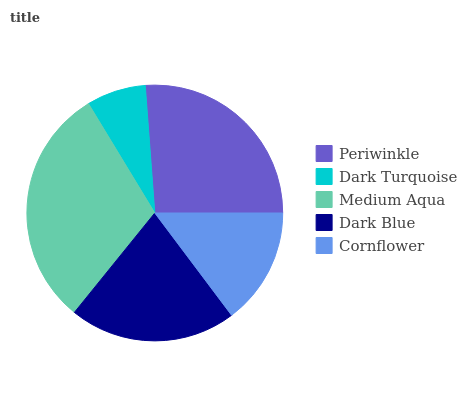Is Dark Turquoise the minimum?
Answer yes or no. Yes. Is Medium Aqua the maximum?
Answer yes or no. Yes. Is Medium Aqua the minimum?
Answer yes or no. No. Is Dark Turquoise the maximum?
Answer yes or no. No. Is Medium Aqua greater than Dark Turquoise?
Answer yes or no. Yes. Is Dark Turquoise less than Medium Aqua?
Answer yes or no. Yes. Is Dark Turquoise greater than Medium Aqua?
Answer yes or no. No. Is Medium Aqua less than Dark Turquoise?
Answer yes or no. No. Is Dark Blue the high median?
Answer yes or no. Yes. Is Dark Blue the low median?
Answer yes or no. Yes. Is Dark Turquoise the high median?
Answer yes or no. No. Is Cornflower the low median?
Answer yes or no. No. 